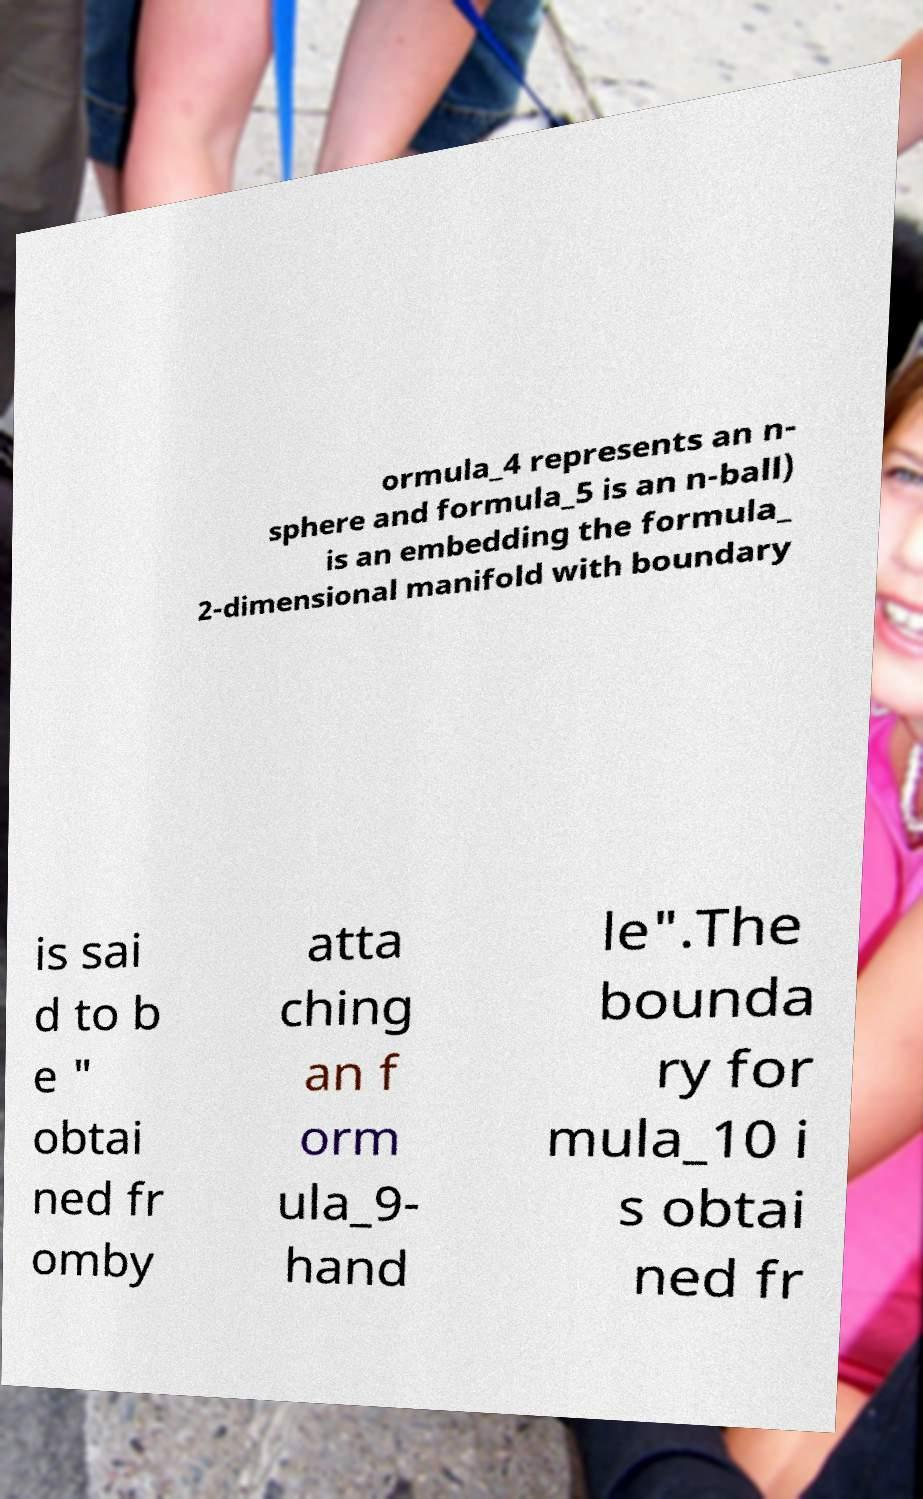Can you read and provide the text displayed in the image?This photo seems to have some interesting text. Can you extract and type it out for me? ormula_4 represents an n- sphere and formula_5 is an n-ball) is an embedding the formula_ 2-dimensional manifold with boundary is sai d to b e " obtai ned fr omby atta ching an f orm ula_9- hand le".The bounda ry for mula_10 i s obtai ned fr 